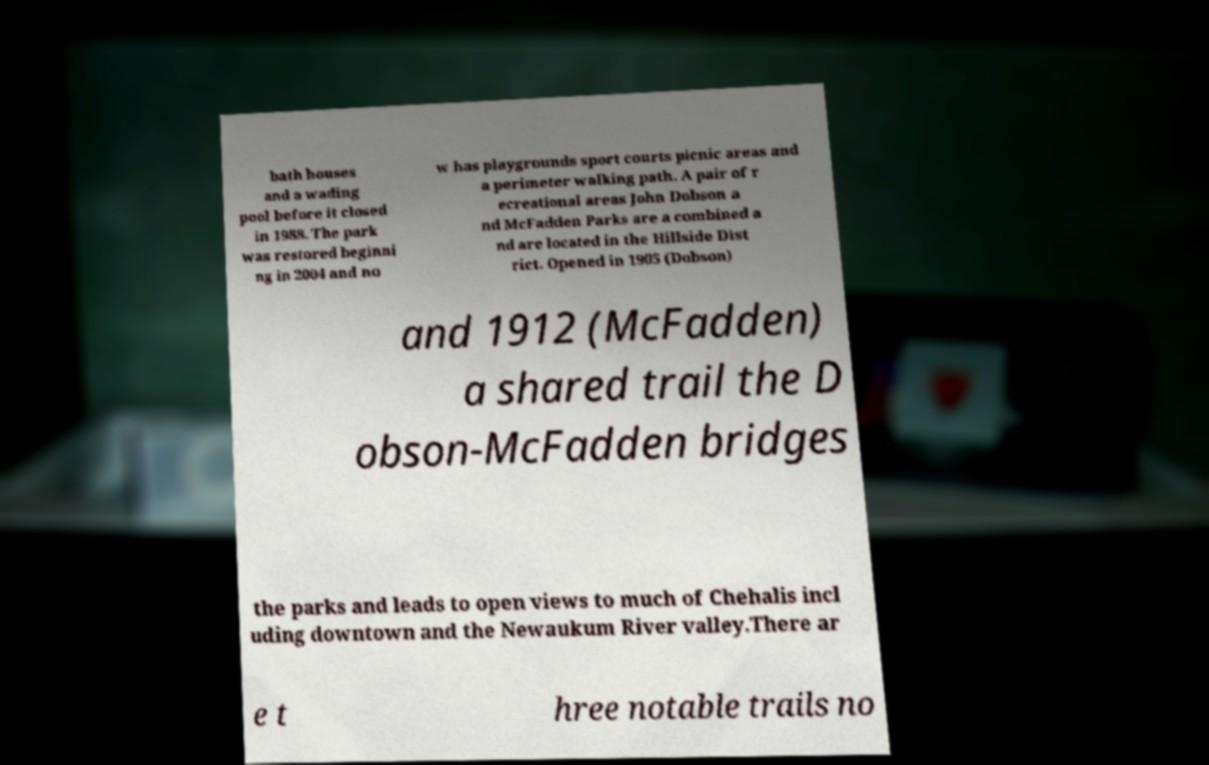Can you accurately transcribe the text from the provided image for me? bath houses and a wading pool before it closed in 1988. The park was restored beginni ng in 2004 and no w has playgrounds sport courts picnic areas and a perimeter walking path. A pair of r ecreational areas John Dobson a nd McFadden Parks are a combined a nd are located in the Hillside Dist rict. Opened in 1905 (Dobson) and 1912 (McFadden) a shared trail the D obson-McFadden bridges the parks and leads to open views to much of Chehalis incl uding downtown and the Newaukum River valley.There ar e t hree notable trails no 